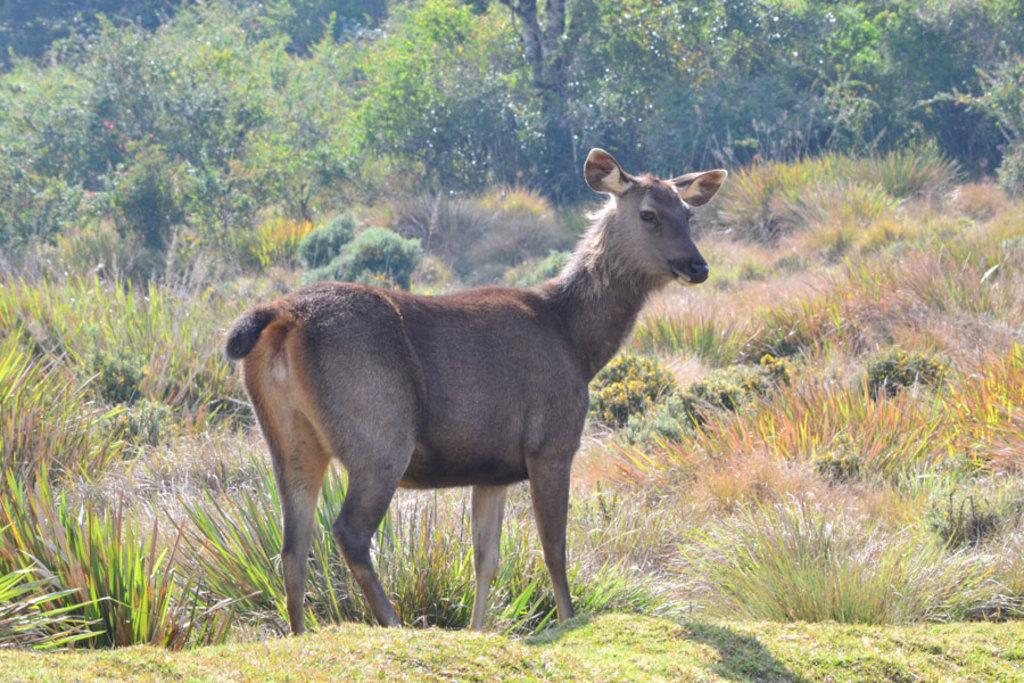Please provide a concise description of this image. In this image we can see a deer, there are some trees, plants, grass. 